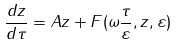Convert formula to latex. <formula><loc_0><loc_0><loc_500><loc_500>\frac { d z } { d \tau } = A z + F ( \omega \frac { \tau } { \varepsilon } , z , \varepsilon )</formula> 